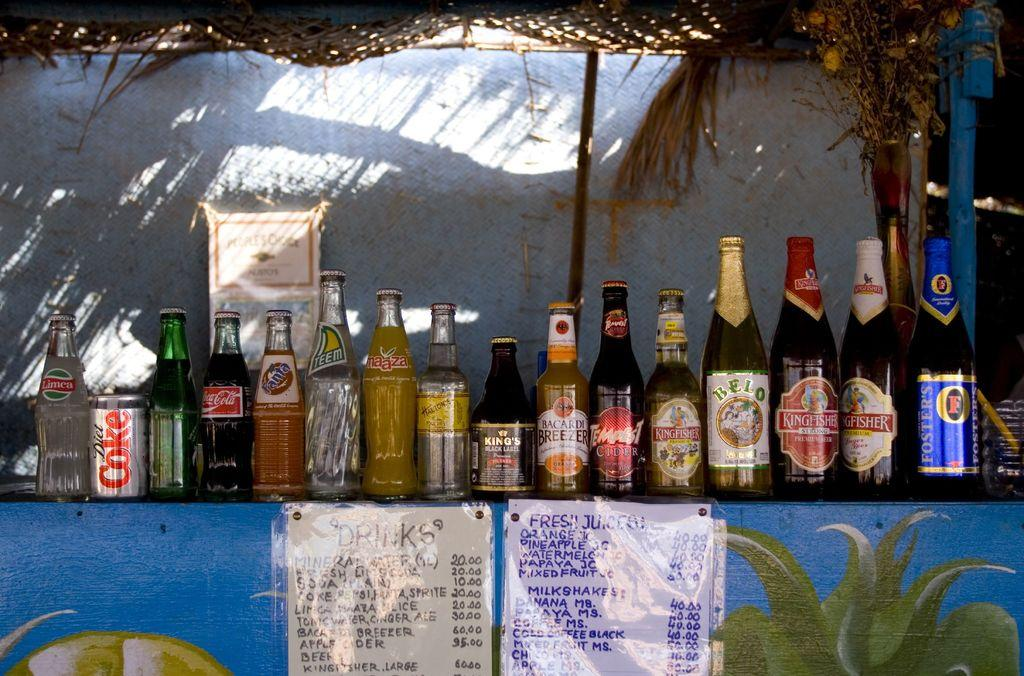What types of bottles can be seen in the image? There are different types of drink bottles and wine bottles in the image. Where are the bottles located? The bottles are placed on a table. What else can be found on the table in the image? There are two papers stuck to the table. What is visible in the background of the image? There is a wall and a stick in the background of the image. What type of circle is present in the image? There is no circle present in the image. Can you describe the bedroom in the image? The image does not depict a bedroom; it shows bottles on a table with a wall and a stick in the background. 